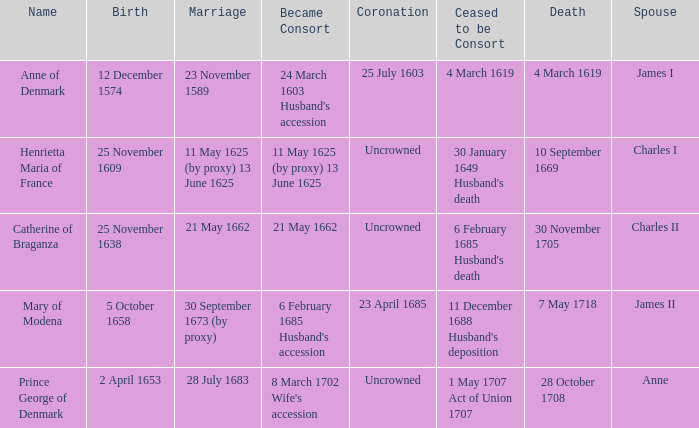When was the date of death for the person married to Charles II? 30 November 1705. 